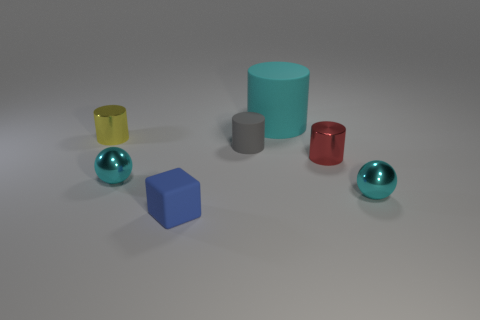Add 2 small metallic cylinders. How many objects exist? 9 Subtract all yellow cylinders. How many cylinders are left? 3 Subtract 1 cylinders. How many cylinders are left? 3 Subtract all red cylinders. How many cylinders are left? 3 Subtract all cylinders. How many objects are left? 3 Subtract all blue blocks. Subtract all blue things. How many objects are left? 5 Add 1 cyan rubber cylinders. How many cyan rubber cylinders are left? 2 Add 5 green shiny spheres. How many green shiny spheres exist? 5 Subtract 1 yellow cylinders. How many objects are left? 6 Subtract all purple cubes. Subtract all red spheres. How many cubes are left? 1 